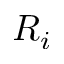<formula> <loc_0><loc_0><loc_500><loc_500>R _ { i }</formula> 